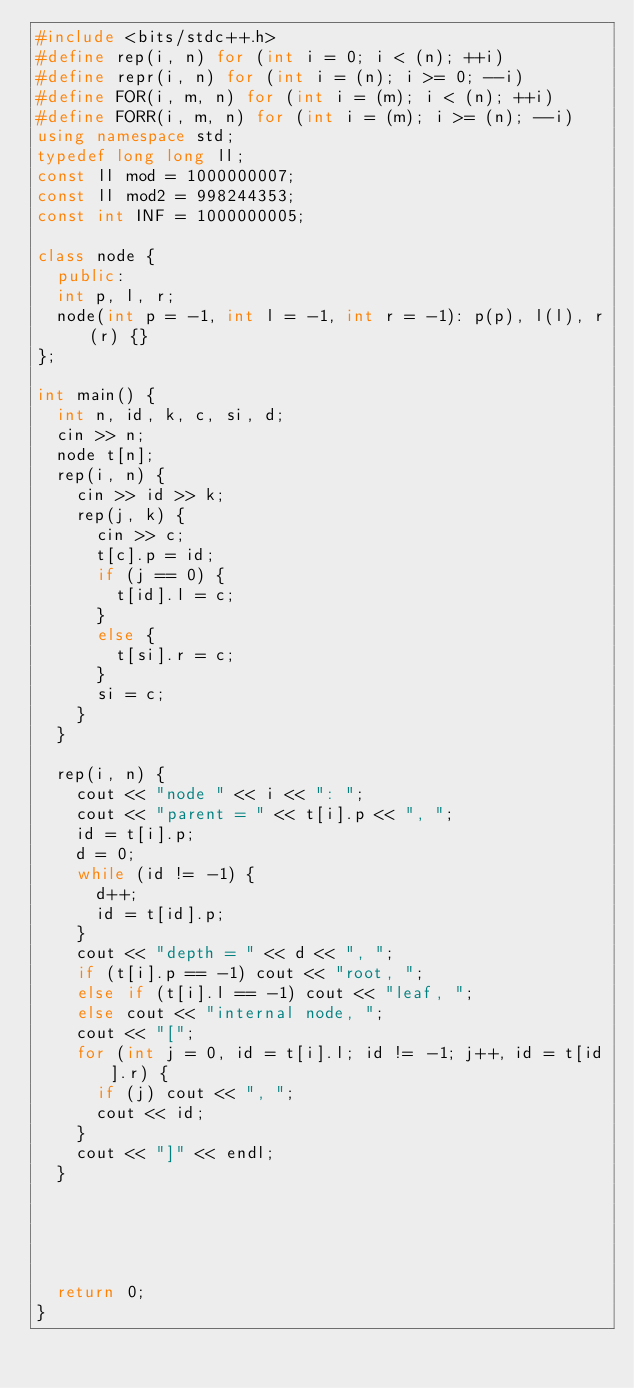<code> <loc_0><loc_0><loc_500><loc_500><_C++_>#include <bits/stdc++.h>
#define rep(i, n) for (int i = 0; i < (n); ++i)
#define repr(i, n) for (int i = (n); i >= 0; --i)
#define FOR(i, m, n) for (int i = (m); i < (n); ++i)
#define FORR(i, m, n) for (int i = (m); i >= (n); --i)
using namespace std;
typedef long long ll;
const ll mod = 1000000007;
const ll mod2 = 998244353;
const int INF = 1000000005;

class node {
  public:
  int p, l, r;
  node(int p = -1, int l = -1, int r = -1): p(p), l(l), r(r) {}
};

int main() {
  int n, id, k, c, si, d;
  cin >> n;
  node t[n];
  rep(i, n) {
    cin >> id >> k;
    rep(j, k) {
      cin >> c;
      t[c].p = id;
      if (j == 0) {
        t[id].l = c;
      }
      else {
        t[si].r = c;
      }
      si = c;
    }
  }

  rep(i, n) {
    cout << "node " << i << ": ";
    cout << "parent = " << t[i].p << ", ";
    id = t[i].p;
    d = 0;
    while (id != -1) {
      d++;
      id = t[id].p;
    }
    cout << "depth = " << d << ", ";
    if (t[i].p == -1) cout << "root, ";
    else if (t[i].l == -1) cout << "leaf, ";
    else cout << "internal node, ";
    cout << "[";
    for (int j = 0, id = t[i].l; id != -1; j++, id = t[id].r) {
      if (j) cout << ", ";
      cout << id;
    }
    cout << "]" << endl;
  }




  
  return 0;
}
</code> 